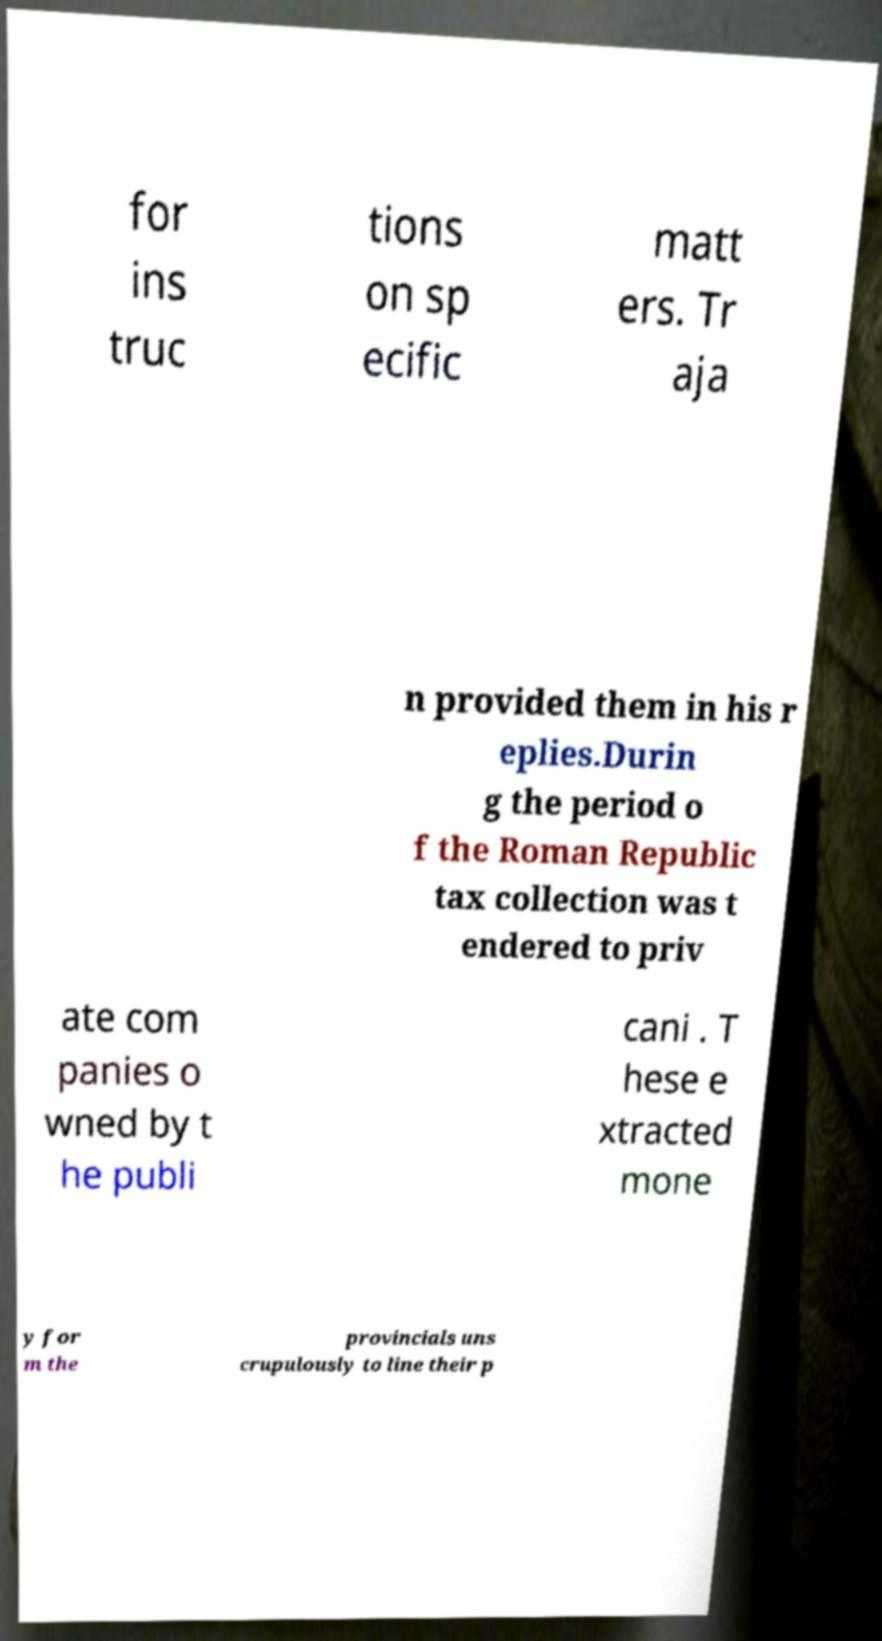Could you assist in decoding the text presented in this image and type it out clearly? for ins truc tions on sp ecific matt ers. Tr aja n provided them in his r eplies.Durin g the period o f the Roman Republic tax collection was t endered to priv ate com panies o wned by t he publi cani . T hese e xtracted mone y for m the provincials uns crupulously to line their p 